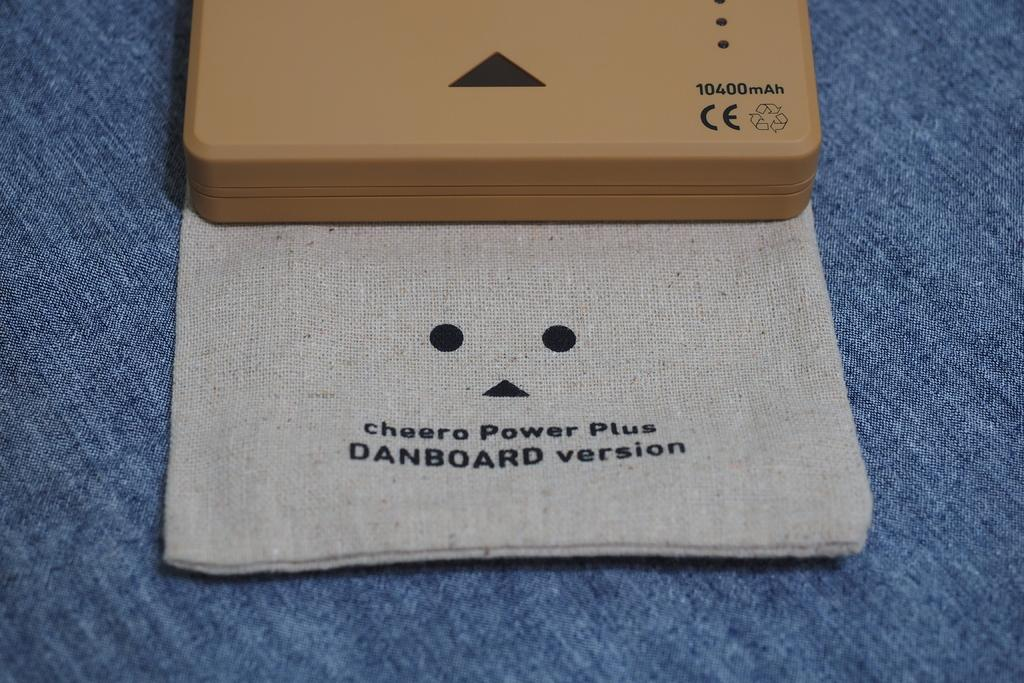<image>
Summarize the visual content of the image. A cloth that says  cheero Power Plus sits under a box on a blue cloth. 